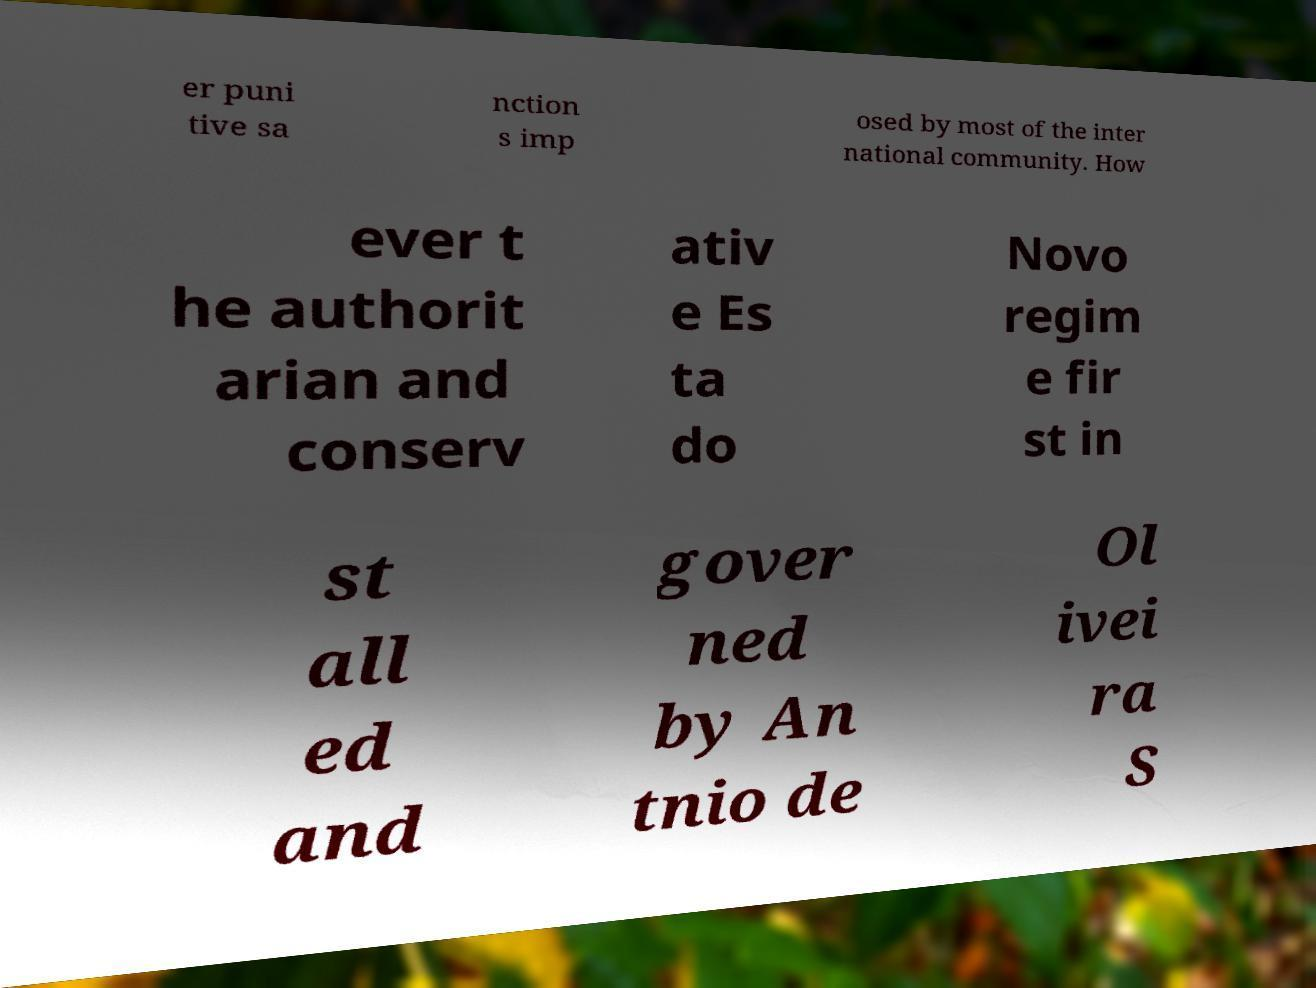I need the written content from this picture converted into text. Can you do that? er puni tive sa nction s imp osed by most of the inter national community. How ever t he authorit arian and conserv ativ e Es ta do Novo regim e fir st in st all ed and gover ned by An tnio de Ol ivei ra S 